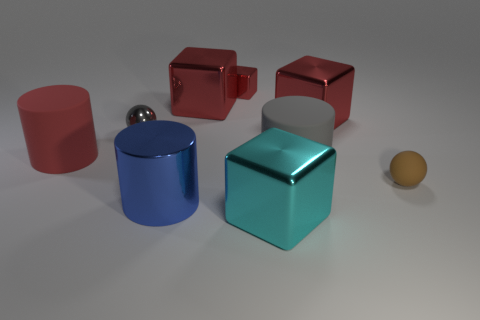The big cylinder that is to the left of the tiny block and behind the tiny brown rubber ball is made of what material?
Provide a succinct answer. Rubber. What is the size of the other object that is the same shape as the tiny brown matte object?
Keep it short and to the point. Small. Are there any large matte cylinders that have the same color as the small metallic sphere?
Offer a very short reply. Yes. There is a cylinder that is the same color as the tiny metal cube; what is its material?
Your answer should be compact. Rubber. What number of big objects are the same color as the tiny metallic cube?
Provide a short and direct response. 3. How many things are either small balls right of the cyan block or red things?
Your answer should be compact. 5. What is the color of the large cylinder that is made of the same material as the tiny gray ball?
Your answer should be very brief. Blue. Are there any red objects of the same size as the brown thing?
Give a very brief answer. Yes. What number of objects are cubes in front of the big blue thing or large metal blocks that are on the right side of the gray sphere?
Keep it short and to the point. 3. There is a metal object that is the same size as the metal ball; what is its shape?
Your answer should be compact. Cube. 